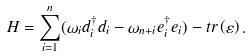<formula> <loc_0><loc_0><loc_500><loc_500>H = \sum _ { i = 1 } ^ { n } ( \omega _ { i } d _ { i } ^ { \dag } d _ { i } - \omega _ { n + i } e _ { i } ^ { \dag } e _ { i } ) - t r \left ( \varepsilon \right ) .</formula> 